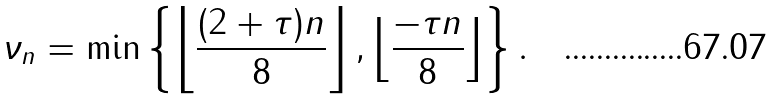Convert formula to latex. <formula><loc_0><loc_0><loc_500><loc_500>\nu _ { n } = \min \left \{ \left \lfloor \frac { ( 2 + \tau ) n } { 8 } \right \rfloor , \left \lfloor \frac { - \tau n } { 8 } \right \rfloor \right \} .</formula> 